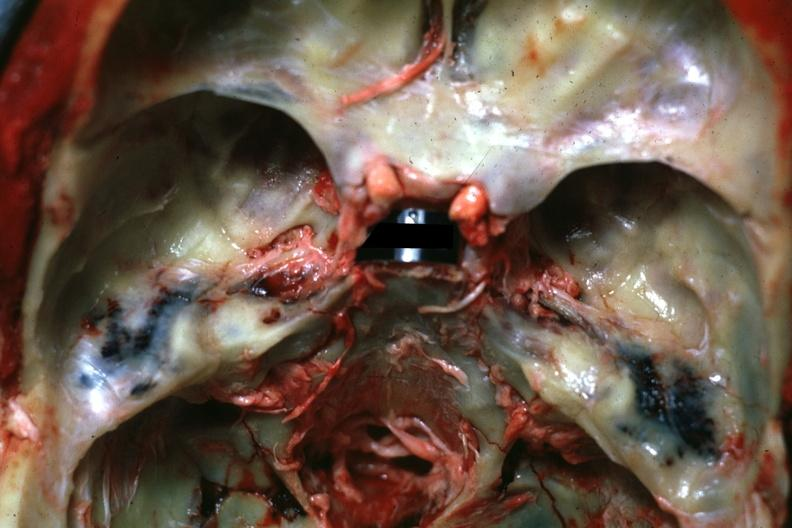what is present?
Answer the question using a single word or phrase. Bone 